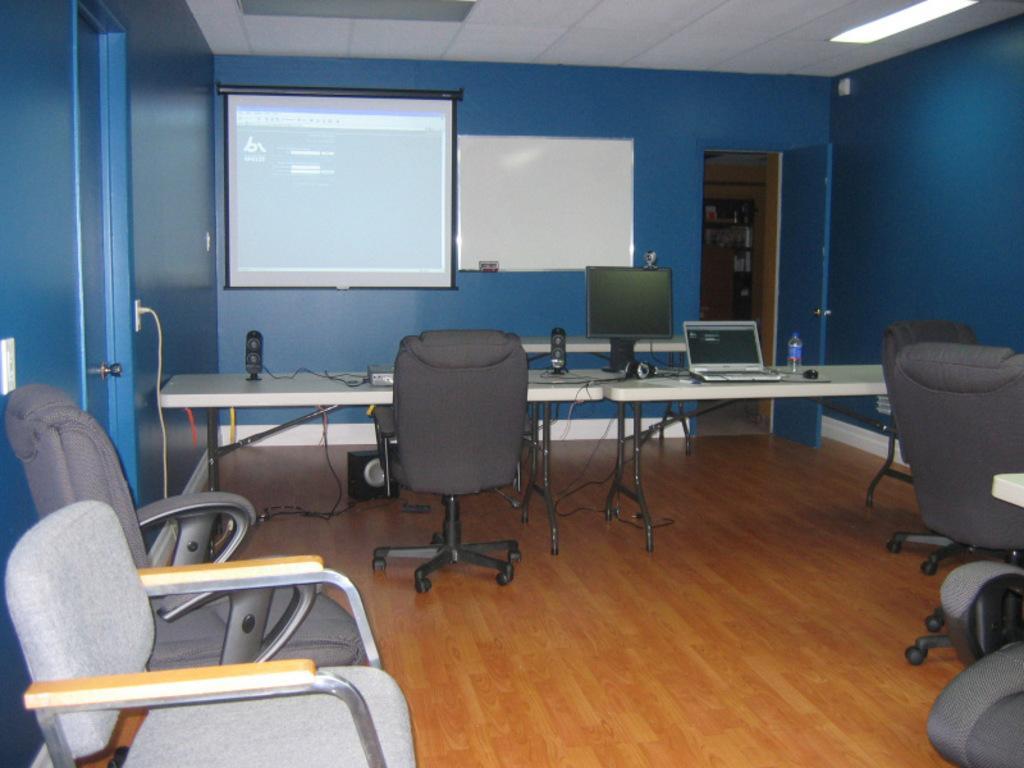Could you give a brief overview of what you see in this image? In this image there are chairs and tables, on top of the tables there are speakers, a monitor and a laptop and a bottle of water, behind the table there is a board and a screen on the wall, beside the board there is an open door. 